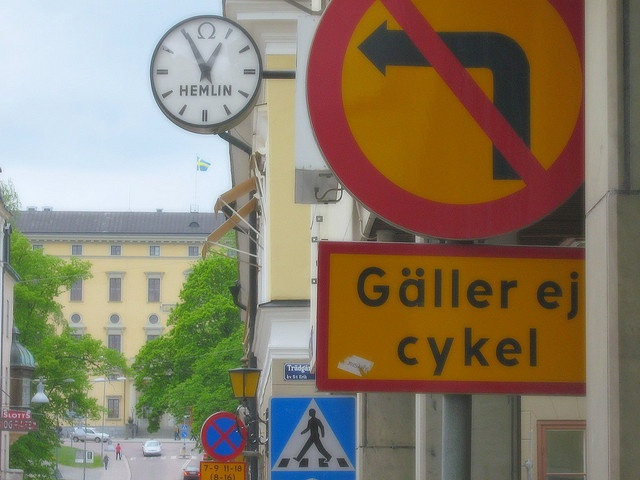Describe the objects in this image and their specific colors. I can see clock in lavender, darkgray, lightgray, and gray tones, car in lavender, darkgray, lightgray, and gray tones, car in lavender, lightgray, darkgray, and lightblue tones, people in lavender, gray, and black tones, and car in lavender, gray, darkgray, brown, and lightblue tones in this image. 